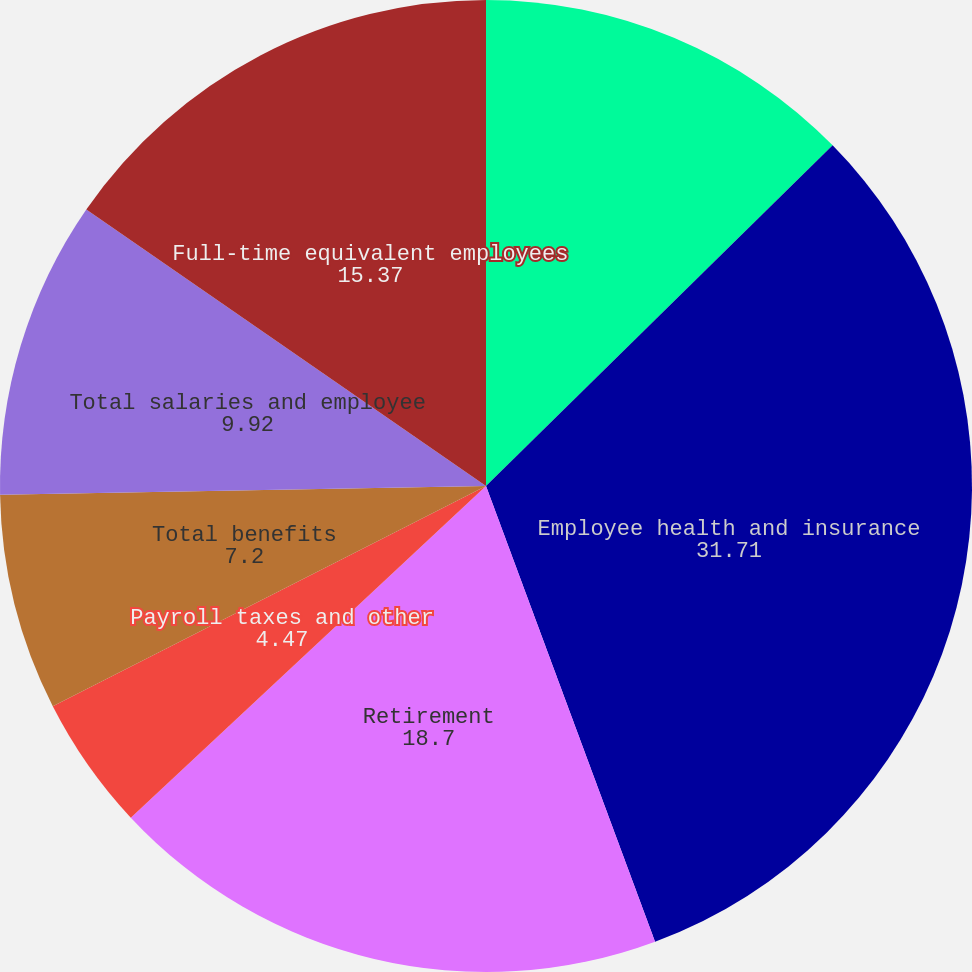<chart> <loc_0><loc_0><loc_500><loc_500><pie_chart><fcel>Salaries and bonuses<fcel>Employee health and insurance<fcel>Retirement<fcel>Payroll taxes and other<fcel>Total benefits<fcel>Total salaries and employee<fcel>Full-time equivalent employees<nl><fcel>12.64%<fcel>31.71%<fcel>18.7%<fcel>4.47%<fcel>7.2%<fcel>9.92%<fcel>15.37%<nl></chart> 